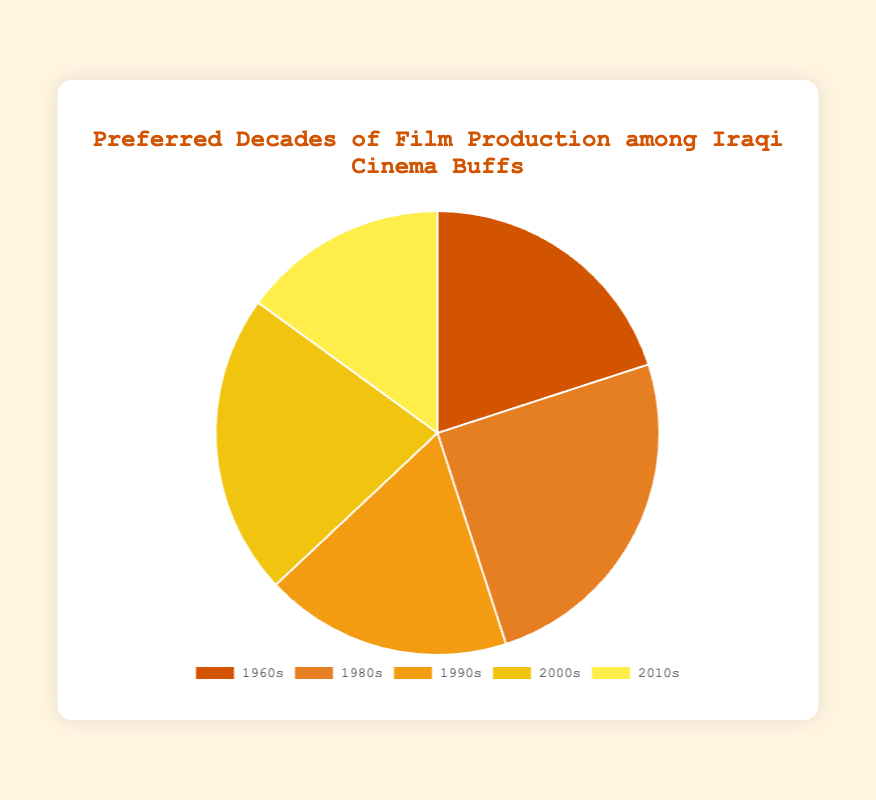What percentage of Iraqi cinema buffs prefer films from the 2000s? The chart clearly shows that 22% of Iraqi cinema buffs prefer films from the 2000s.
Answer: 22% Which decade has the highest preference among Iraqi cinema buffs? By observing the percentages in the pie chart, the 1980s have the highest preference at 25%.
Answer: 1980s How much higher is the preference for films from the 1980s compared to the 2010s? Subtract the percentage for the 2010s (15%) from the percentage for the 1980s (25%): 25% - 15% = 10%.
Answer: 10% Comparing the 1960s and the 1990s, which decade has a higher preference and by how much? Subtract the percentage for the 1960s (20%) from the percentage for the 1990s (18%): 20% - 18% = 2%. Thus, the 1960s have a higher preference by 2%.
Answer: 1960s, by 2% What is the total percentage of Iraqi cinema buffs that prefer films from the 2000s and the 2010s combined? Add the percentages for the 2000s (22%) and the 2010s (15%): 22% + 15% = 37%.
Answer: 37% If you combine the preferences for the 1960s and 1980s, what percentage of Iraqi cinema buffs does this represent? Add the percentages for the 1960s (20%) and the 1980s (25%): 20% + 25% = 45%.
Answer: 45% What color represents the decade with the lowest preference in the pie chart? The decade with the lowest preference is the 2010s, which is represented by the lightest-yellow section in the chart.
Answer: light yellow What is the average percentage preference across all decades shown in the pie chart? Sum all the percentages (20% + 25% + 18% + 22% + 15%) = 100 and divide by the number of decades (5): 100 / 5 = 20%.
Answer: 20% Between the 1990s and the 2000s, which decade has a lower percentage preference and by how much? Subtract the percentage for the 1990s (18%) from the percentage for the 2000s (22%): 22% - 18% = 4%. Thus, the 1990s have a lower preference by 4%.
Answer: 1990s, by 4% If you consider the 1980s and 2000s together, what percentage of Iraqi cinema buffs prefer films from these decades? Add the percentages for the 1980s (25%) and the 2000s (22%): 25% + 22% = 47%.
Answer: 47% 